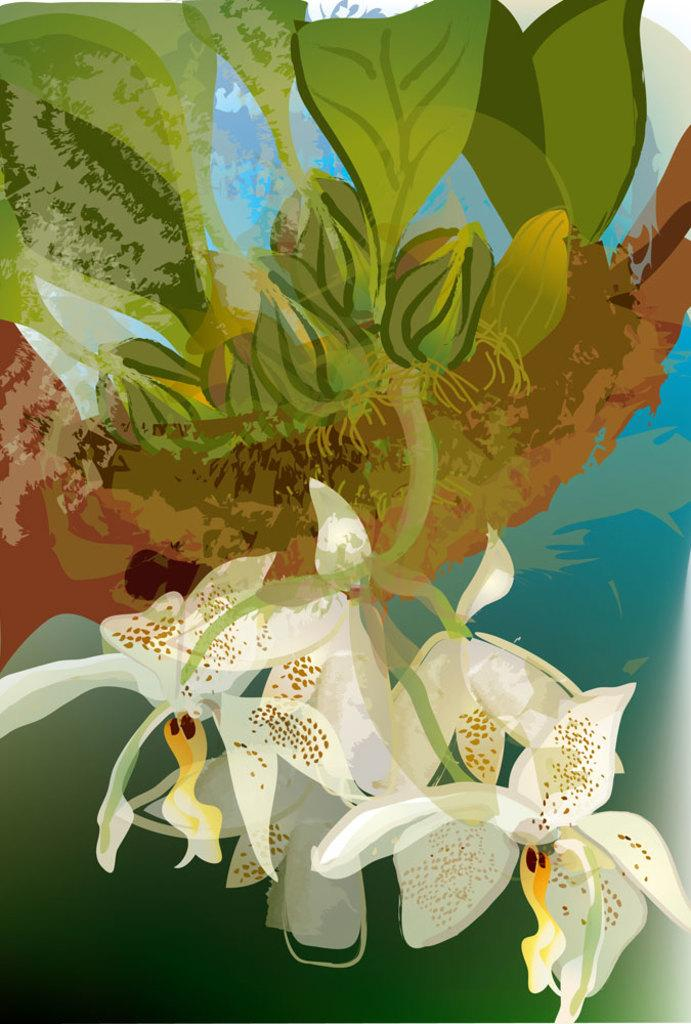What type of artwork is depicted in the image? The image is a painting. What kind of flowers can be seen in the painting? There are white flowers in the painting. What other elements are present in the painting? There are plants in the painting. What type of birthday decoration can be seen in the painting? There is no mention of a birthday or any birthday decorations in the painting. How many clovers are visible in the painting? There is no mention of clovers in the painting; it features white flowers and plants. 